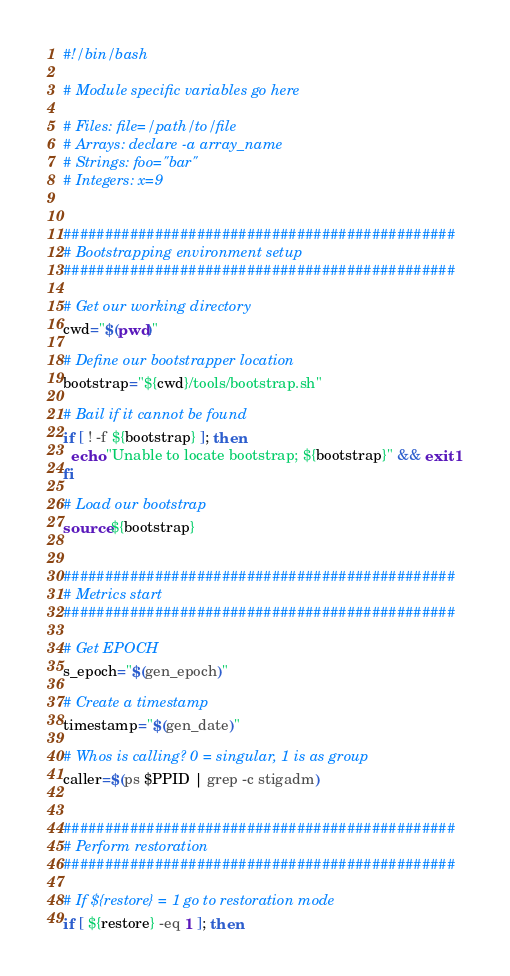Convert code to text. <code><loc_0><loc_0><loc_500><loc_500><_Bash_>#!/bin/bash

# Module specific variables go here

# Files: file=/path/to/file
# Arrays: declare -a array_name
# Strings: foo="bar"
# Integers: x=9


###############################################
# Bootstrapping environment setup
###############################################

# Get our working directory
cwd="$(pwd)"

# Define our bootstrapper location
bootstrap="${cwd}/tools/bootstrap.sh"

# Bail if it cannot be found
if [ ! -f ${bootstrap} ]; then
  echo "Unable to locate bootstrap; ${bootstrap}" && exit 1
fi

# Load our bootstrap
source ${bootstrap}


###############################################
# Metrics start
###############################################

# Get EPOCH
s_epoch="$(gen_epoch)"

# Create a timestamp
timestamp="$(gen_date)"

# Whos is calling? 0 = singular, 1 is as group
caller=$(ps $PPID | grep -c stigadm)


###############################################
# Perform restoration
###############################################

# If ${restore} = 1 go to restoration mode
if [ ${restore} -eq 1 ]; then</code> 